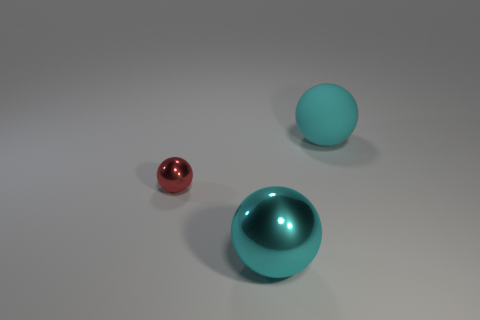Subtract all big cyan balls. How many balls are left? 1 Add 1 small objects. How many objects exist? 4 Subtract all green cylinders. How many cyan balls are left? 2 Subtract all red spheres. How many spheres are left? 2 Subtract 2 balls. How many balls are left? 1 Subtract all green spheres. Subtract all green cubes. How many spheres are left? 3 Subtract all big green shiny blocks. Subtract all big balls. How many objects are left? 1 Add 1 red balls. How many red balls are left? 2 Add 1 red metallic cylinders. How many red metallic cylinders exist? 1 Subtract 0 gray spheres. How many objects are left? 3 